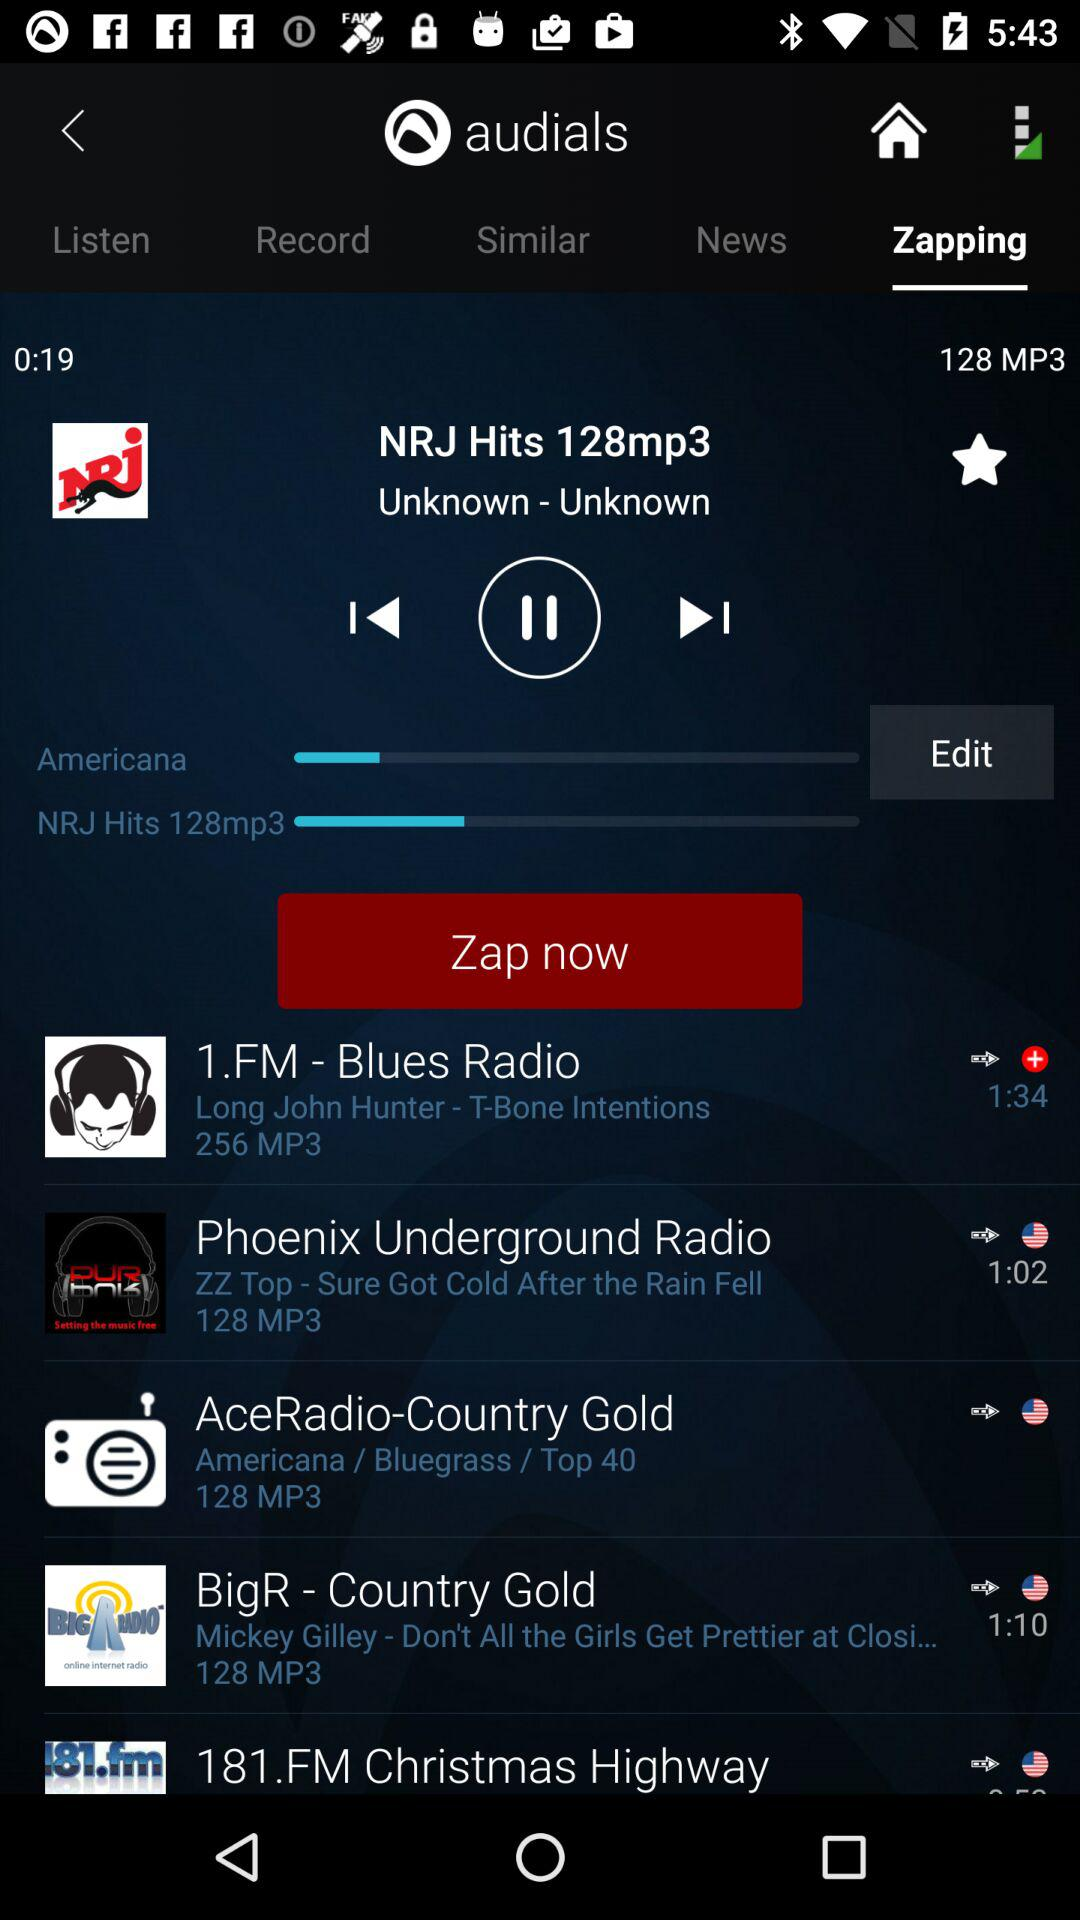For how long has the "NRJ Hits" music been played? The "NRJ Hits" music has been played for 19 seconds. 